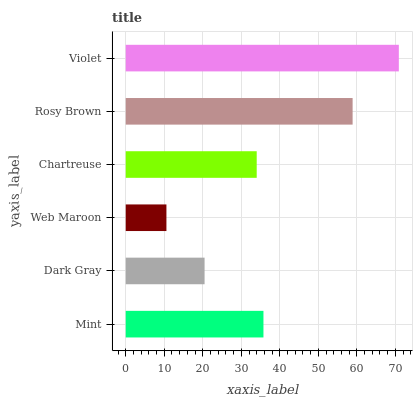Is Web Maroon the minimum?
Answer yes or no. Yes. Is Violet the maximum?
Answer yes or no. Yes. Is Dark Gray the minimum?
Answer yes or no. No. Is Dark Gray the maximum?
Answer yes or no. No. Is Mint greater than Dark Gray?
Answer yes or no. Yes. Is Dark Gray less than Mint?
Answer yes or no. Yes. Is Dark Gray greater than Mint?
Answer yes or no. No. Is Mint less than Dark Gray?
Answer yes or no. No. Is Mint the high median?
Answer yes or no. Yes. Is Chartreuse the low median?
Answer yes or no. Yes. Is Web Maroon the high median?
Answer yes or no. No. Is Rosy Brown the low median?
Answer yes or no. No. 